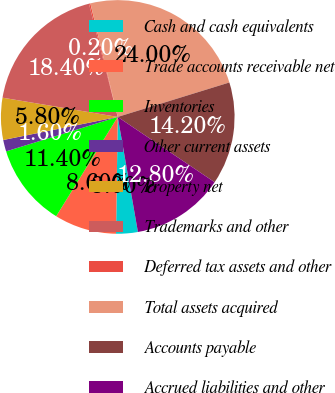Convert chart to OTSL. <chart><loc_0><loc_0><loc_500><loc_500><pie_chart><fcel>Cash and cash equivalents<fcel>Trade accounts receivable net<fcel>Inventories<fcel>Other current assets<fcel>Property net<fcel>Trademarks and other<fcel>Deferred tax assets and other<fcel>Total assets acquired<fcel>Accounts payable<fcel>Accrued liabilities and other<nl><fcel>3.0%<fcel>8.6%<fcel>11.4%<fcel>1.6%<fcel>5.8%<fcel>18.4%<fcel>0.2%<fcel>24.0%<fcel>14.2%<fcel>12.8%<nl></chart> 